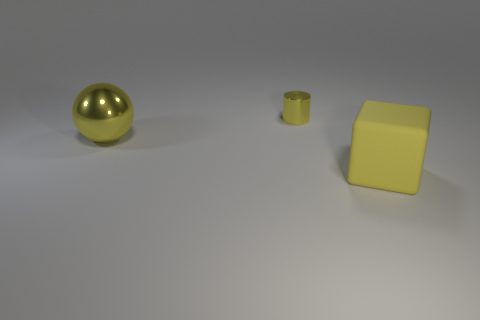Is the color of the sphere the same as the small object?
Provide a succinct answer. Yes. How many yellow objects are tiny matte things or large matte cubes?
Offer a terse response. 1. Are there an equal number of matte objects left of the small metal thing and large things in front of the ball?
Provide a succinct answer. No. The shiny object to the left of the yellow shiny thing that is to the right of the large thing behind the big cube is what color?
Make the answer very short. Yellow. Is there anything else that has the same color as the ball?
Offer a terse response. Yes. There is a big thing that is the same color as the big matte cube; what is its shape?
Keep it short and to the point. Sphere. What is the size of the yellow object behind the big metal ball?
Ensure brevity in your answer.  Small. There is a thing that is the same size as the metal sphere; what shape is it?
Offer a very short reply. Cube. Do the large yellow thing that is to the left of the cube and the object that is to the right of the yellow shiny cylinder have the same material?
Keep it short and to the point. No. What is the material of the large thing on the right side of the object that is left of the cylinder?
Keep it short and to the point. Rubber. 